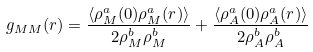Convert formula to latex. <formula><loc_0><loc_0><loc_500><loc_500>g _ { M M } ( r ) = \frac { \langle \rho ^ { a } _ { M } ( 0 ) \rho ^ { a } _ { M } ( r ) \rangle } { 2 \rho ^ { b } _ { M } \rho ^ { b } _ { M } } + \frac { \langle \rho ^ { a } _ { A } ( 0 ) \rho ^ { a } _ { A } ( r ) \rangle } { 2 \rho ^ { b } _ { A } \rho ^ { b } _ { A } }</formula> 